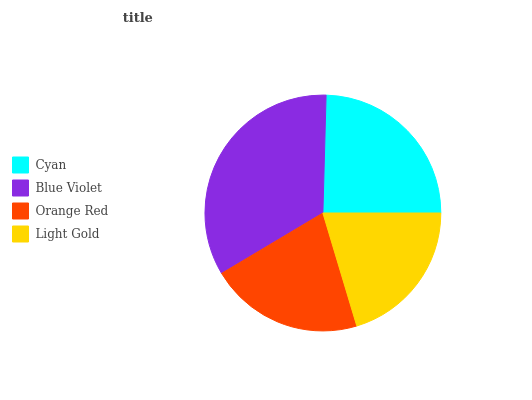Is Light Gold the minimum?
Answer yes or no. Yes. Is Blue Violet the maximum?
Answer yes or no. Yes. Is Orange Red the minimum?
Answer yes or no. No. Is Orange Red the maximum?
Answer yes or no. No. Is Blue Violet greater than Orange Red?
Answer yes or no. Yes. Is Orange Red less than Blue Violet?
Answer yes or no. Yes. Is Orange Red greater than Blue Violet?
Answer yes or no. No. Is Blue Violet less than Orange Red?
Answer yes or no. No. Is Cyan the high median?
Answer yes or no. Yes. Is Orange Red the low median?
Answer yes or no. Yes. Is Light Gold the high median?
Answer yes or no. No. Is Blue Violet the low median?
Answer yes or no. No. 